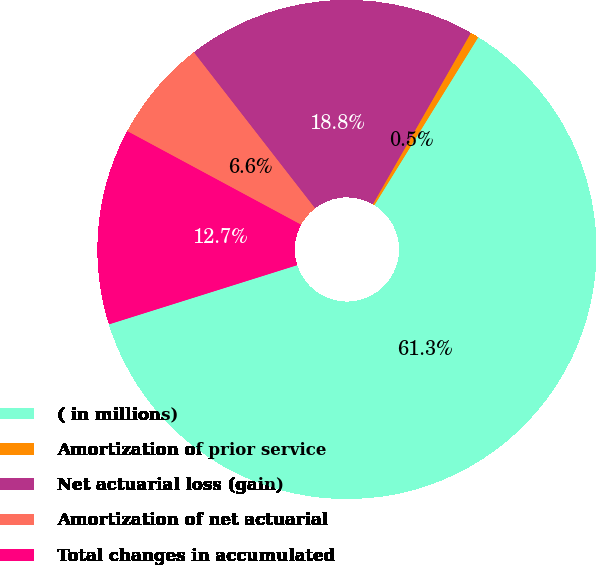<chart> <loc_0><loc_0><loc_500><loc_500><pie_chart><fcel>( in millions)<fcel>Amortization of prior service<fcel>Net actuarial loss (gain)<fcel>Amortization of net actuarial<fcel>Total changes in accumulated<nl><fcel>61.34%<fcel>0.55%<fcel>18.78%<fcel>6.63%<fcel>12.71%<nl></chart> 